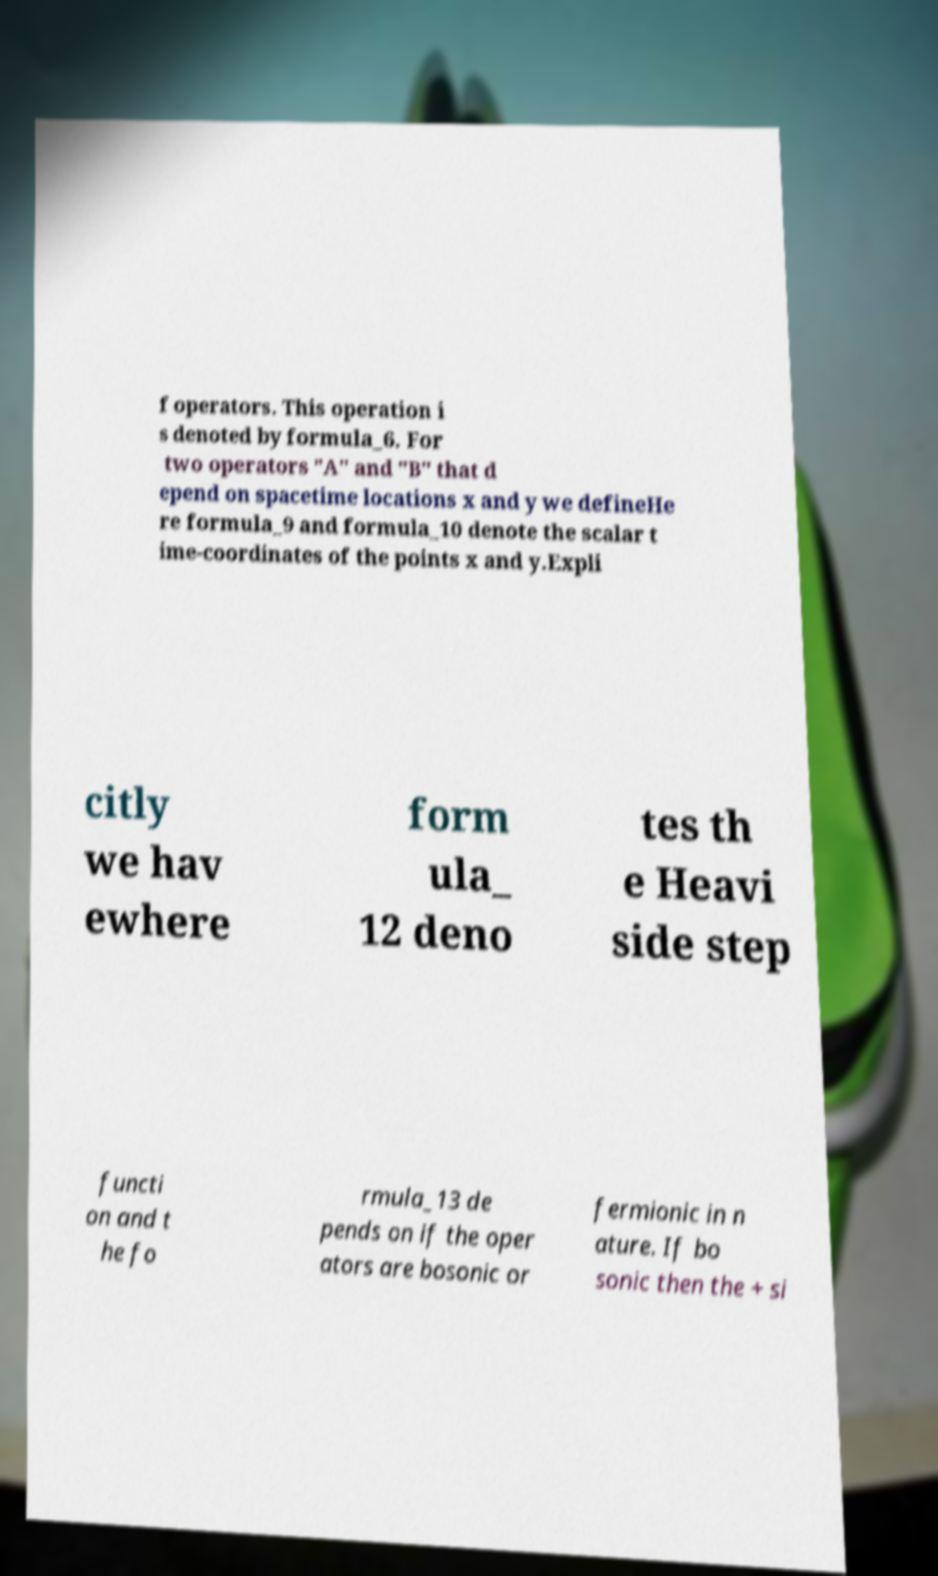Can you accurately transcribe the text from the provided image for me? f operators. This operation i s denoted by formula_6. For two operators "A" and "B" that d epend on spacetime locations x and y we defineHe re formula_9 and formula_10 denote the scalar t ime-coordinates of the points x and y.Expli citly we hav ewhere form ula_ 12 deno tes th e Heavi side step functi on and t he fo rmula_13 de pends on if the oper ators are bosonic or fermionic in n ature. If bo sonic then the + si 